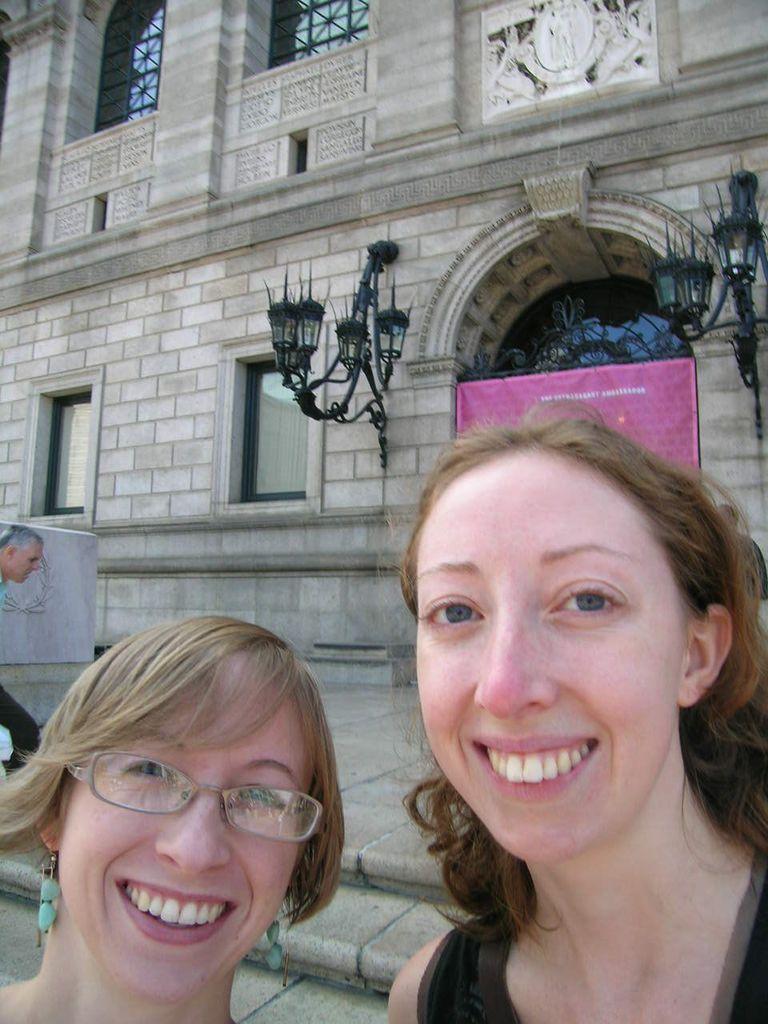In one or two sentences, can you explain what this image depicts? In this image there is a woman wearing spectacles. Beside there is a woman. Left side a person is walking on the stairs. There is a banner attached to the wall having windows. Lights are attached to the wall. Left side there is an object on the floor. 